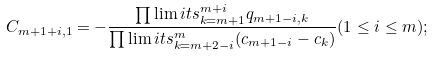<formula> <loc_0><loc_0><loc_500><loc_500>C _ { m + 1 + i , 1 } = - \frac { \prod \lim i t s _ { k = m + 1 } ^ { m + i } q _ { m + 1 - i , k } } { \prod \lim i t s _ { k = m + 2 - i } ^ { m } ( c _ { m + 1 - i } - c _ { k } ) } ( 1 \leq i \leq m ) ;</formula> 